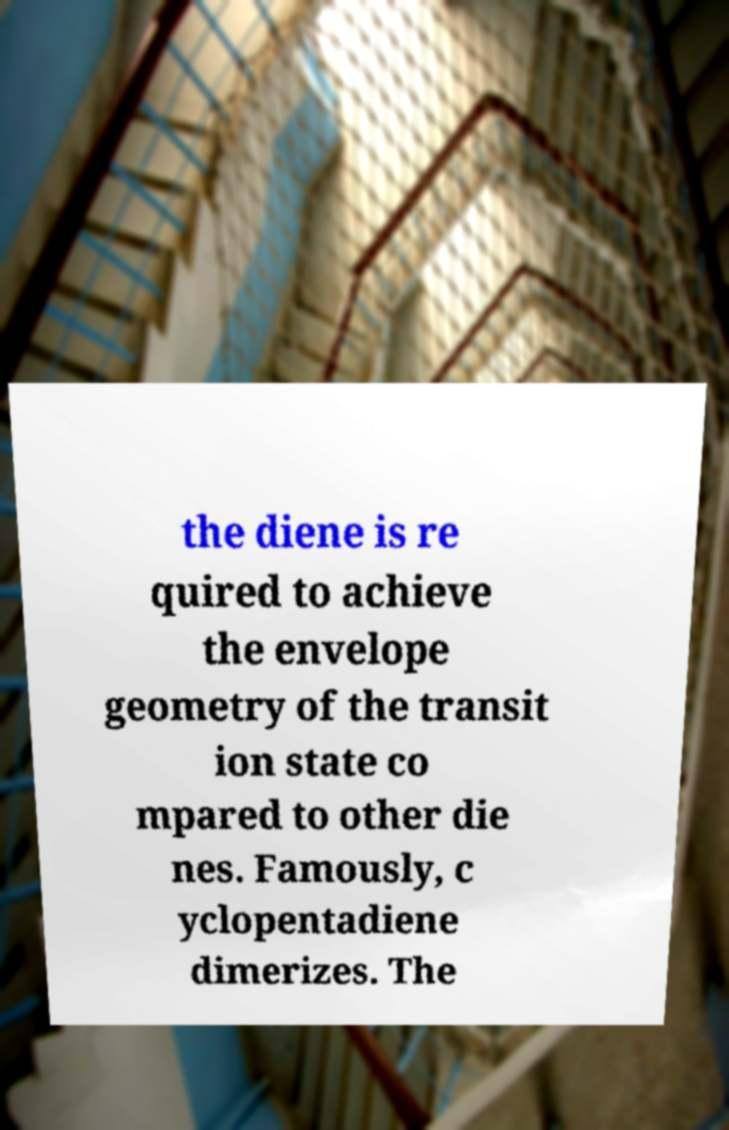Could you extract and type out the text from this image? the diene is re quired to achieve the envelope geometry of the transit ion state co mpared to other die nes. Famously, c yclopentadiene dimerizes. The 